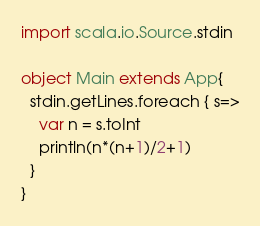<code> <loc_0><loc_0><loc_500><loc_500><_Scala_>import scala.io.Source.stdin

object Main extends App{
  stdin.getLines.foreach { s=>
    var n = s.toInt
    println(n*(n+1)/2+1)
  }
}</code> 